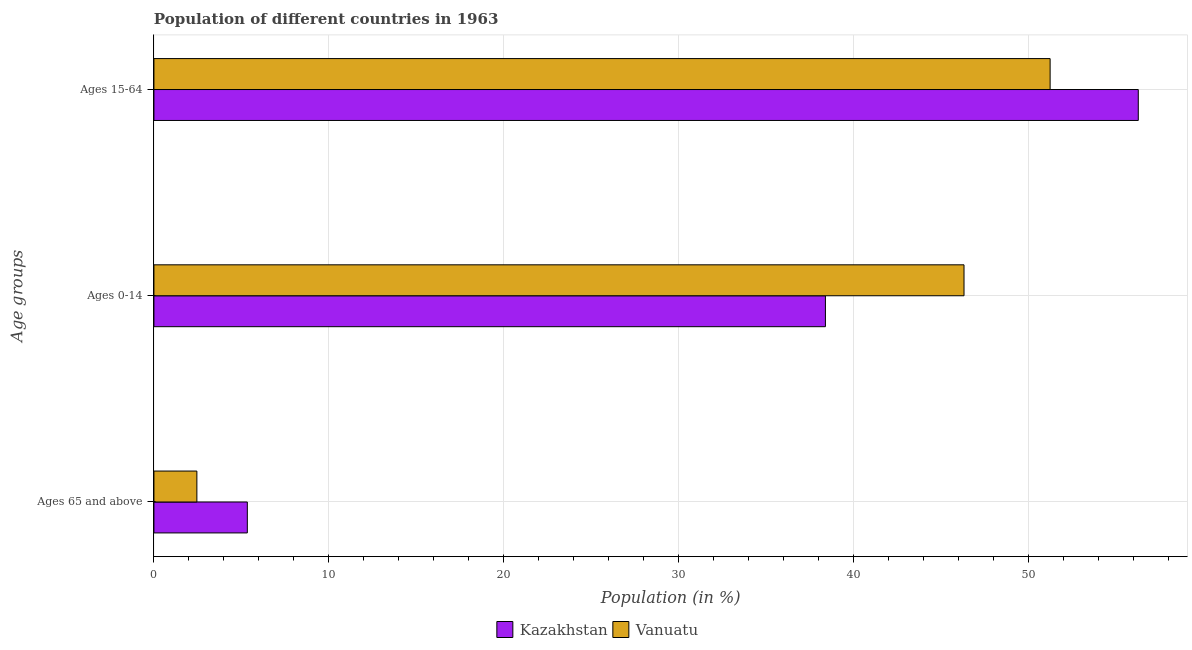How many groups of bars are there?
Give a very brief answer. 3. What is the label of the 1st group of bars from the top?
Offer a very short reply. Ages 15-64. What is the percentage of population within the age-group 15-64 in Kazakhstan?
Keep it short and to the point. 56.27. Across all countries, what is the maximum percentage of population within the age-group 0-14?
Ensure brevity in your answer.  46.31. Across all countries, what is the minimum percentage of population within the age-group of 65 and above?
Keep it short and to the point. 2.46. In which country was the percentage of population within the age-group 15-64 maximum?
Your response must be concise. Kazakhstan. In which country was the percentage of population within the age-group 15-64 minimum?
Provide a succinct answer. Vanuatu. What is the total percentage of population within the age-group 0-14 in the graph?
Offer a very short reply. 84.7. What is the difference between the percentage of population within the age-group 15-64 in Vanuatu and that in Kazakhstan?
Provide a short and direct response. -5.04. What is the difference between the percentage of population within the age-group 15-64 in Kazakhstan and the percentage of population within the age-group of 65 and above in Vanuatu?
Offer a terse response. 53.82. What is the average percentage of population within the age-group 15-64 per country?
Your answer should be compact. 53.75. What is the difference between the percentage of population within the age-group 15-64 and percentage of population within the age-group 0-14 in Kazakhstan?
Ensure brevity in your answer.  17.88. In how many countries, is the percentage of population within the age-group 15-64 greater than 28 %?
Provide a short and direct response. 2. What is the ratio of the percentage of population within the age-group of 65 and above in Vanuatu to that in Kazakhstan?
Offer a very short reply. 0.46. Is the difference between the percentage of population within the age-group 15-64 in Vanuatu and Kazakhstan greater than the difference between the percentage of population within the age-group of 65 and above in Vanuatu and Kazakhstan?
Offer a terse response. No. What is the difference between the highest and the second highest percentage of population within the age-group of 65 and above?
Ensure brevity in your answer.  2.88. What is the difference between the highest and the lowest percentage of population within the age-group 15-64?
Offer a terse response. 5.04. In how many countries, is the percentage of population within the age-group 15-64 greater than the average percentage of population within the age-group 15-64 taken over all countries?
Your response must be concise. 1. Is the sum of the percentage of population within the age-group of 65 and above in Vanuatu and Kazakhstan greater than the maximum percentage of population within the age-group 15-64 across all countries?
Keep it short and to the point. No. What does the 2nd bar from the top in Ages 15-64 represents?
Your response must be concise. Kazakhstan. What does the 2nd bar from the bottom in Ages 15-64 represents?
Provide a succinct answer. Vanuatu. Is it the case that in every country, the sum of the percentage of population within the age-group of 65 and above and percentage of population within the age-group 0-14 is greater than the percentage of population within the age-group 15-64?
Offer a very short reply. No. How many bars are there?
Ensure brevity in your answer.  6. Are all the bars in the graph horizontal?
Provide a succinct answer. Yes. Does the graph contain any zero values?
Your answer should be very brief. No. Does the graph contain grids?
Provide a succinct answer. Yes. What is the title of the graph?
Make the answer very short. Population of different countries in 1963. What is the label or title of the X-axis?
Provide a short and direct response. Population (in %). What is the label or title of the Y-axis?
Offer a very short reply. Age groups. What is the Population (in %) of Kazakhstan in Ages 65 and above?
Ensure brevity in your answer.  5.34. What is the Population (in %) in Vanuatu in Ages 65 and above?
Your response must be concise. 2.46. What is the Population (in %) of Kazakhstan in Ages 0-14?
Offer a very short reply. 38.39. What is the Population (in %) of Vanuatu in Ages 0-14?
Provide a succinct answer. 46.31. What is the Population (in %) of Kazakhstan in Ages 15-64?
Ensure brevity in your answer.  56.27. What is the Population (in %) of Vanuatu in Ages 15-64?
Provide a succinct answer. 51.23. Across all Age groups, what is the maximum Population (in %) of Kazakhstan?
Ensure brevity in your answer.  56.27. Across all Age groups, what is the maximum Population (in %) of Vanuatu?
Offer a very short reply. 51.23. Across all Age groups, what is the minimum Population (in %) of Kazakhstan?
Offer a terse response. 5.34. Across all Age groups, what is the minimum Population (in %) of Vanuatu?
Ensure brevity in your answer.  2.46. What is the total Population (in %) in Vanuatu in the graph?
Provide a succinct answer. 100. What is the difference between the Population (in %) of Kazakhstan in Ages 65 and above and that in Ages 0-14?
Give a very brief answer. -33.05. What is the difference between the Population (in %) of Vanuatu in Ages 65 and above and that in Ages 0-14?
Your response must be concise. -43.86. What is the difference between the Population (in %) in Kazakhstan in Ages 65 and above and that in Ages 15-64?
Offer a very short reply. -50.93. What is the difference between the Population (in %) in Vanuatu in Ages 65 and above and that in Ages 15-64?
Make the answer very short. -48.78. What is the difference between the Population (in %) of Kazakhstan in Ages 0-14 and that in Ages 15-64?
Give a very brief answer. -17.88. What is the difference between the Population (in %) in Vanuatu in Ages 0-14 and that in Ages 15-64?
Provide a succinct answer. -4.92. What is the difference between the Population (in %) of Kazakhstan in Ages 65 and above and the Population (in %) of Vanuatu in Ages 0-14?
Give a very brief answer. -40.97. What is the difference between the Population (in %) of Kazakhstan in Ages 65 and above and the Population (in %) of Vanuatu in Ages 15-64?
Make the answer very short. -45.89. What is the difference between the Population (in %) of Kazakhstan in Ages 0-14 and the Population (in %) of Vanuatu in Ages 15-64?
Your answer should be compact. -12.85. What is the average Population (in %) in Kazakhstan per Age groups?
Your answer should be very brief. 33.33. What is the average Population (in %) of Vanuatu per Age groups?
Ensure brevity in your answer.  33.33. What is the difference between the Population (in %) in Kazakhstan and Population (in %) in Vanuatu in Ages 65 and above?
Give a very brief answer. 2.88. What is the difference between the Population (in %) of Kazakhstan and Population (in %) of Vanuatu in Ages 0-14?
Ensure brevity in your answer.  -7.92. What is the difference between the Population (in %) of Kazakhstan and Population (in %) of Vanuatu in Ages 15-64?
Your answer should be compact. 5.04. What is the ratio of the Population (in %) in Kazakhstan in Ages 65 and above to that in Ages 0-14?
Your response must be concise. 0.14. What is the ratio of the Population (in %) in Vanuatu in Ages 65 and above to that in Ages 0-14?
Make the answer very short. 0.05. What is the ratio of the Population (in %) in Kazakhstan in Ages 65 and above to that in Ages 15-64?
Ensure brevity in your answer.  0.09. What is the ratio of the Population (in %) in Vanuatu in Ages 65 and above to that in Ages 15-64?
Your answer should be very brief. 0.05. What is the ratio of the Population (in %) of Kazakhstan in Ages 0-14 to that in Ages 15-64?
Give a very brief answer. 0.68. What is the ratio of the Population (in %) of Vanuatu in Ages 0-14 to that in Ages 15-64?
Your answer should be compact. 0.9. What is the difference between the highest and the second highest Population (in %) in Kazakhstan?
Provide a succinct answer. 17.88. What is the difference between the highest and the second highest Population (in %) in Vanuatu?
Provide a succinct answer. 4.92. What is the difference between the highest and the lowest Population (in %) of Kazakhstan?
Make the answer very short. 50.93. What is the difference between the highest and the lowest Population (in %) in Vanuatu?
Provide a short and direct response. 48.78. 